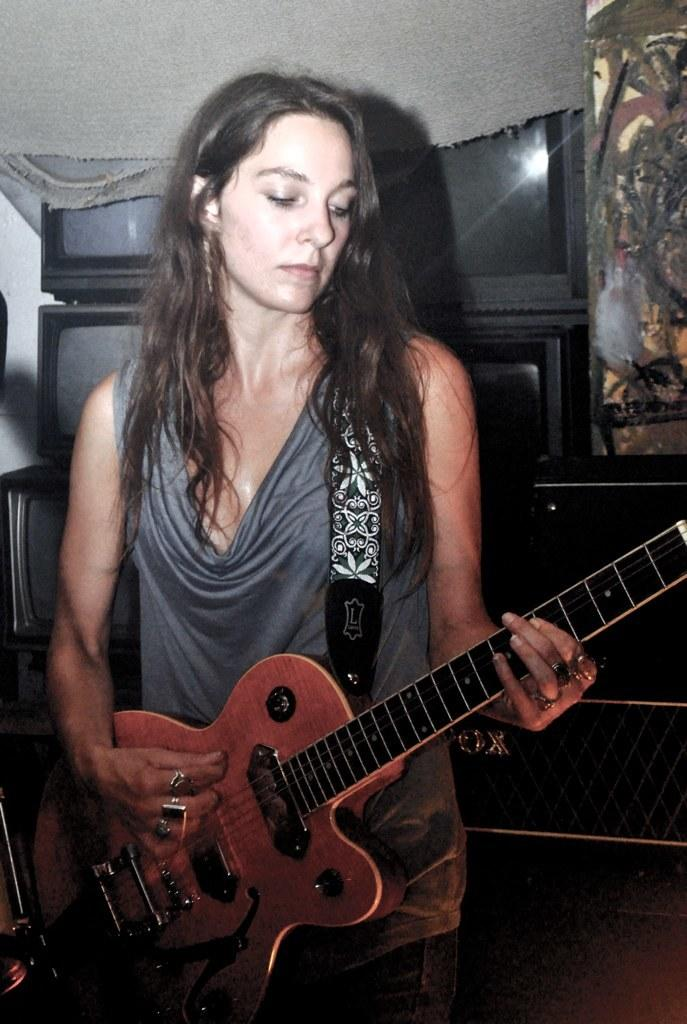What is the main subject of the image? There is a person in the image. What is the person doing in the image? The person is standing and playing a guitar. What is the person wearing in the image? The person is wearing clothes. What can be seen behind the person in the image? There are televisions behind the person. What type of flag is being carried by the boy in the image? There is no boy or flag present in the image; it features a person playing a guitar. 